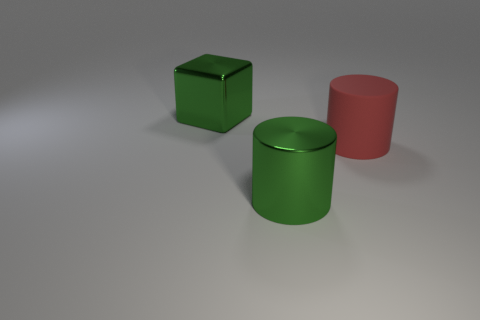Subtract all green cylinders. How many cylinders are left? 1 Subtract all brown balls. How many green cylinders are left? 1 Subtract all cyan cylinders. Subtract all gray balls. How many cylinders are left? 2 Subtract all large green shiny objects. Subtract all small blue cylinders. How many objects are left? 1 Add 2 objects. How many objects are left? 5 Add 1 metal cubes. How many metal cubes exist? 2 Add 3 big blue matte objects. How many objects exist? 6 Subtract 1 green cylinders. How many objects are left? 2 Subtract all cylinders. How many objects are left? 1 Subtract 1 cylinders. How many cylinders are left? 1 